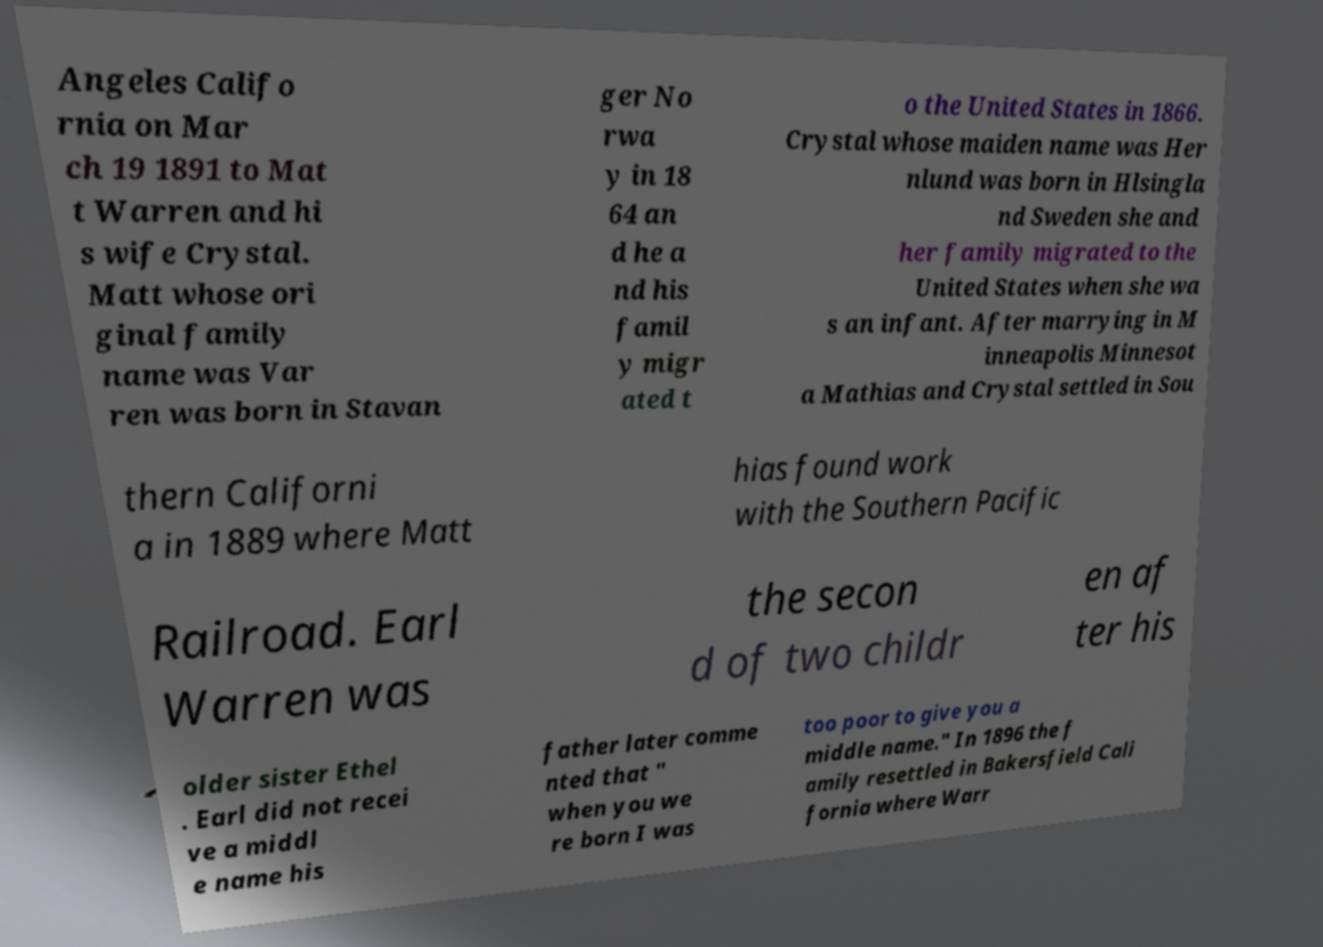For documentation purposes, I need the text within this image transcribed. Could you provide that? Angeles Califo rnia on Mar ch 19 1891 to Mat t Warren and hi s wife Crystal. Matt whose ori ginal family name was Var ren was born in Stavan ger No rwa y in 18 64 an d he a nd his famil y migr ated t o the United States in 1866. Crystal whose maiden name was Her nlund was born in Hlsingla nd Sweden she and her family migrated to the United States when she wa s an infant. After marrying in M inneapolis Minnesot a Mathias and Crystal settled in Sou thern Californi a in 1889 where Matt hias found work with the Southern Pacific Railroad. Earl Warren was the secon d of two childr en af ter his older sister Ethel . Earl did not recei ve a middl e name his father later comme nted that " when you we re born I was too poor to give you a middle name." In 1896 the f amily resettled in Bakersfield Cali fornia where Warr 